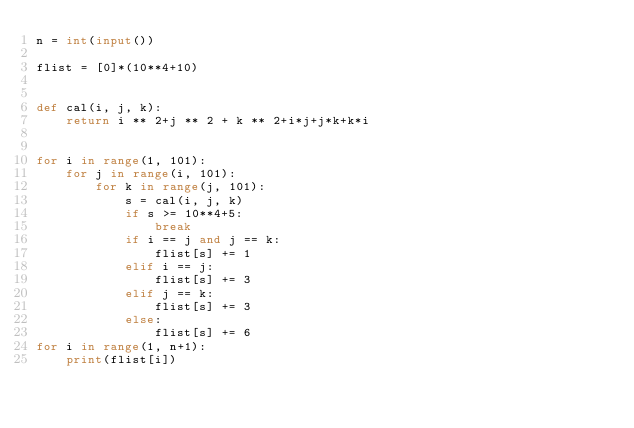<code> <loc_0><loc_0><loc_500><loc_500><_Python_>n = int(input())

flist = [0]*(10**4+10)


def cal(i, j, k):
    return i ** 2+j ** 2 + k ** 2+i*j+j*k+k*i


for i in range(1, 101):
    for j in range(i, 101):
        for k in range(j, 101):
            s = cal(i, j, k)
            if s >= 10**4+5:
                break
            if i == j and j == k:
                flist[s] += 1
            elif i == j:
                flist[s] += 3
            elif j == k:
                flist[s] += 3
            else:
                flist[s] += 6
for i in range(1, n+1):
    print(flist[i])
</code> 